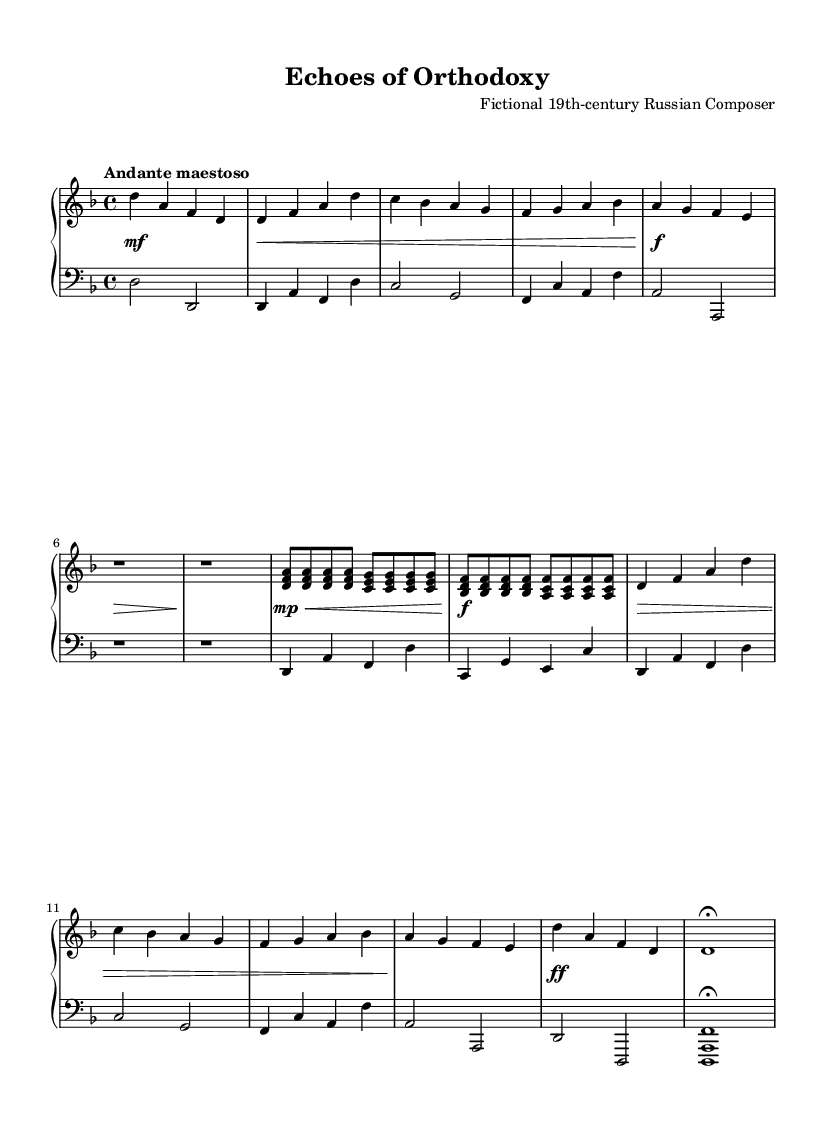What is the key signature of this music? The key signature indicated in the music is D minor, which has one flat, represented by the key signature at the beginning of the staff.
Answer: D minor What is the time signature of this music? The time signature displayed on the sheet music is 4/4, commonly referred to as "common time," which can be identified next to the key signature.
Answer: 4/4 What is the tempo indication of this music? The tempo is noted as "Andante maestoso," which guides the performer on how fast or slow to play the piece. This is provided at the start of the score.
Answer: Andante maestoso How many measures are in the main theme? By counting the individual measures within the main theme section of the score, we find there are a total of four measures, identifiable by their separation in the musical staff.
Answer: Four What is the dynamic marking at the beginning of the piece? The dynamic marking at the beginning indicates a mezzo-fortissimo (mf) level, which suggests a moderate volume, as indicated by the markings before the first note.
Answer: mezzo-fortissimo What does the bell motif represent in this music? The bell motif serves to evoke the sounds of Orthodox church bells, as specified in the context of the composition, and appears prominently at the introduction and conclusion of the piece.
Answer: Orthodox church bells What is the final note of the piece? The final note as indicated in the coda is a D note held as a fermata, suggesting it should be sustained, prominently visible at the end of the score.
Answer: D 